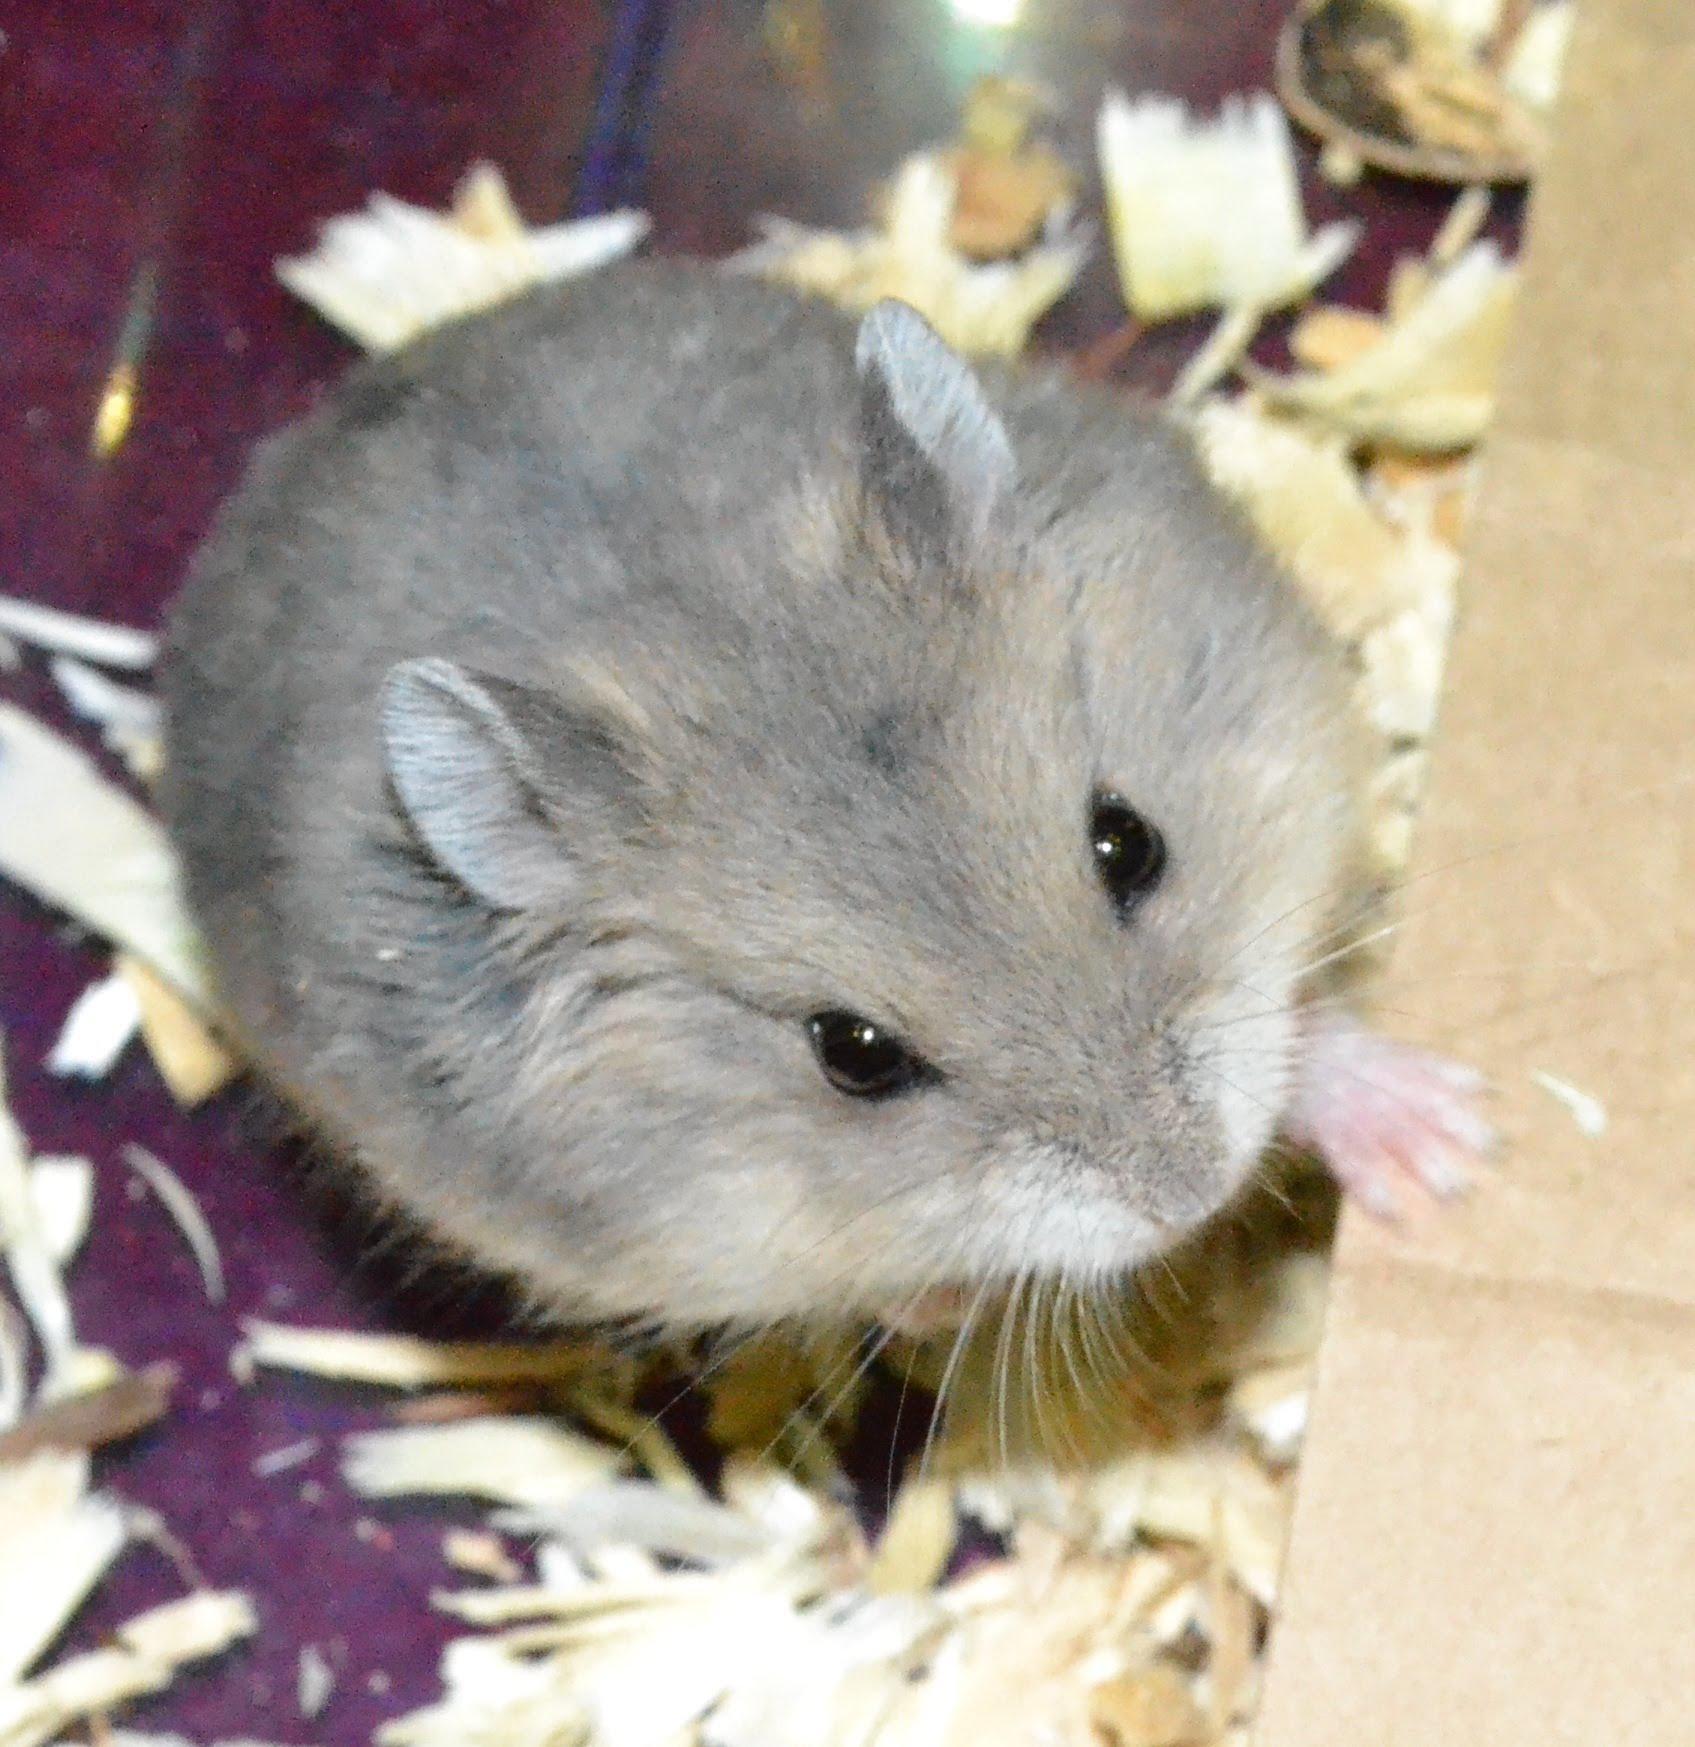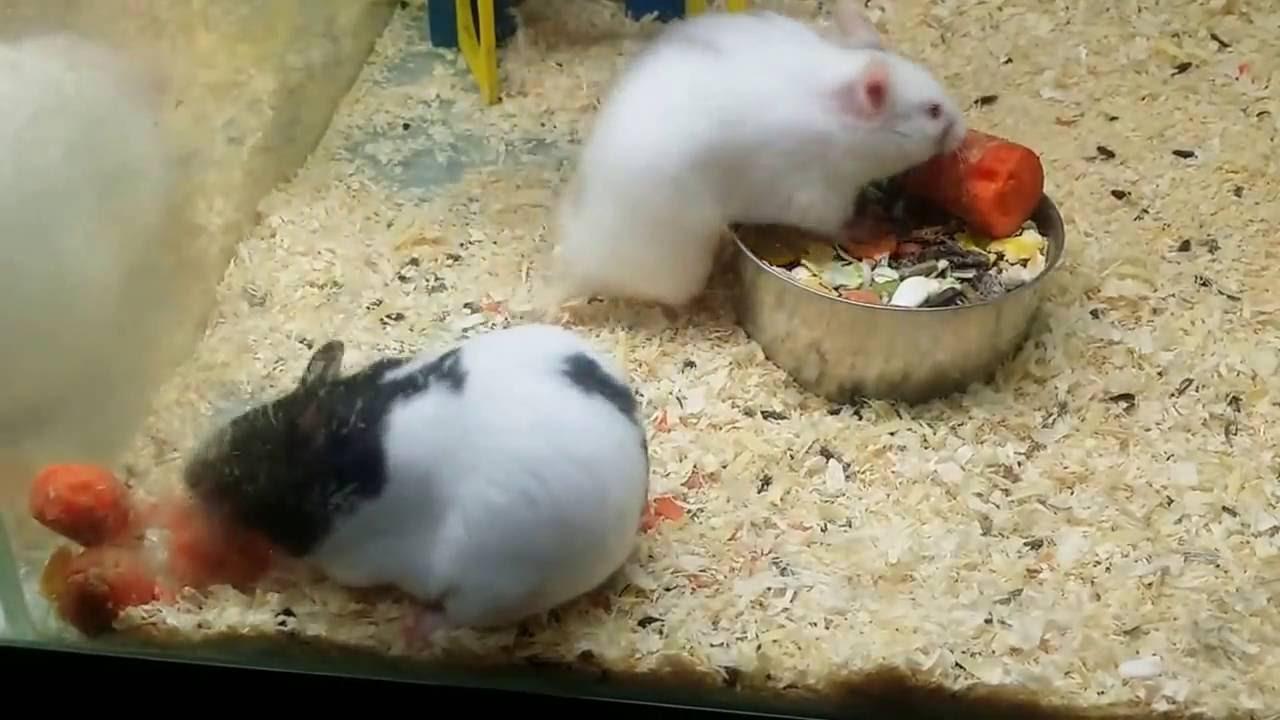The first image is the image on the left, the second image is the image on the right. Assess this claim about the two images: "There is one pair of brown and white hamsters fighting with each other in the image on the left.". Correct or not? Answer yes or no. No. The first image is the image on the left, the second image is the image on the right. Given the left and right images, does the statement "There are in total three hamsters in the images." hold true? Answer yes or no. Yes. 